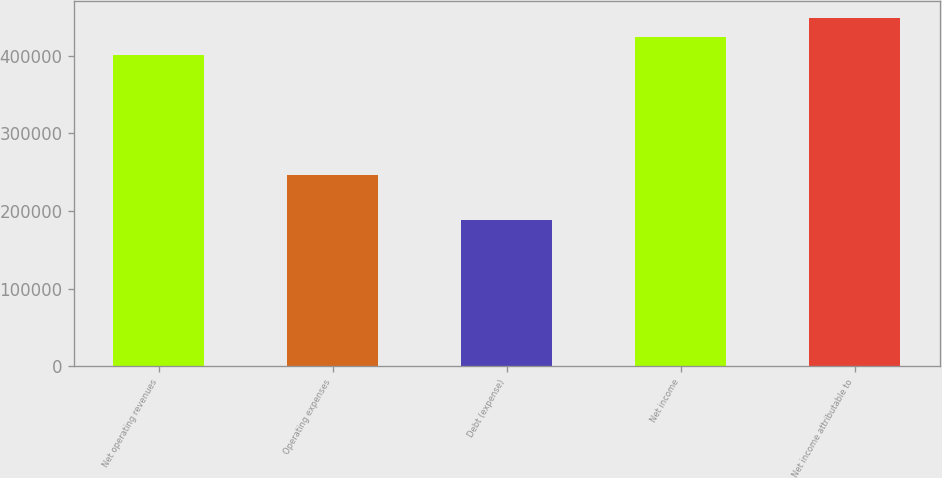Convert chart to OTSL. <chart><loc_0><loc_0><loc_500><loc_500><bar_chart><fcel>Net operating revenues<fcel>Operating expenses<fcel>Debt (expense)<fcel>Net income<fcel>Net income attributable to<nl><fcel>401058<fcel>246578<fcel>188109<fcel>424516<fcel>447973<nl></chart> 